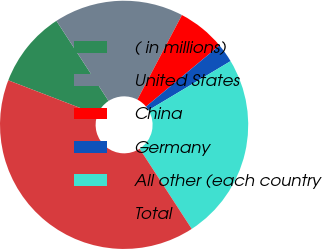Convert chart to OTSL. <chart><loc_0><loc_0><loc_500><loc_500><pie_chart><fcel>( in millions)<fcel>United States<fcel>China<fcel>Germany<fcel>All other (each country<fcel>Total<nl><fcel>9.98%<fcel>16.9%<fcel>6.23%<fcel>2.47%<fcel>24.41%<fcel>40.01%<nl></chart> 